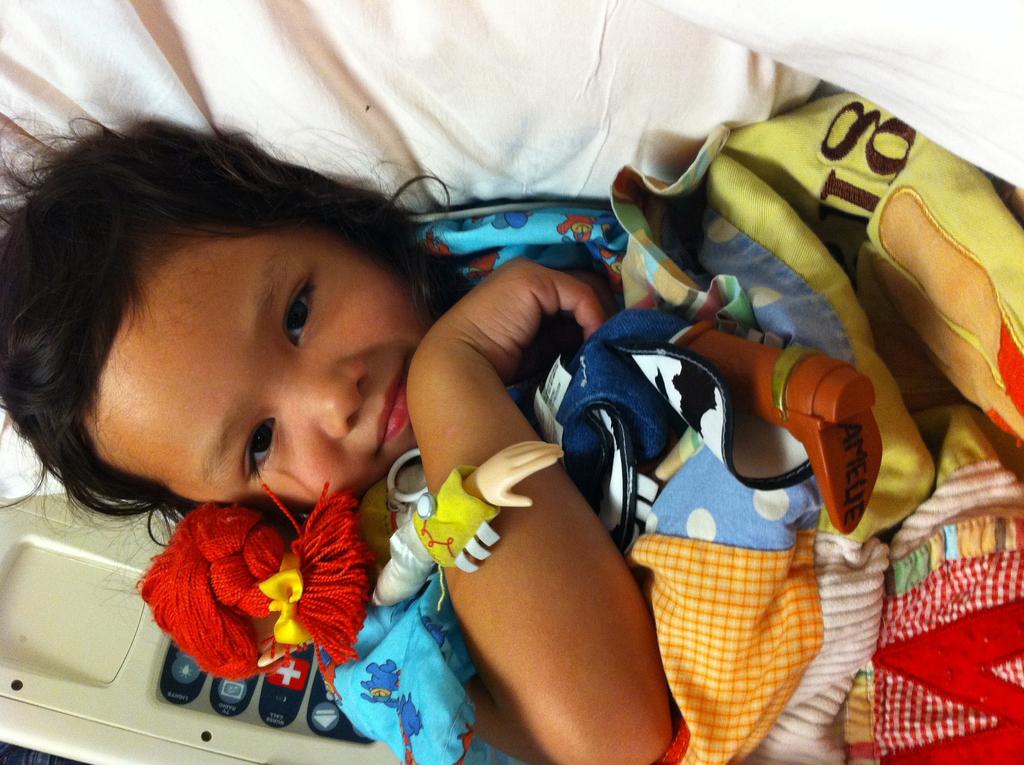What is her name?
Provide a short and direct response. Amelie. 